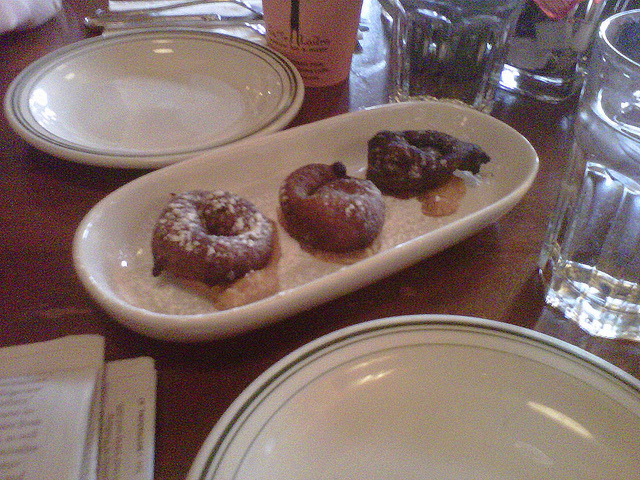Can you describe the donuts on the plate? Certainly! From left to right, the first donut is topped with powdered sugar, the second one has a chocolate glaze, and the third appears to be slightly charred or chocolate as well, with no distinct topping. 